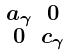<formula> <loc_0><loc_0><loc_500><loc_500>\begin{smallmatrix} a _ { \gamma } & 0 \\ 0 & c _ { \gamma } \end{smallmatrix}</formula> 